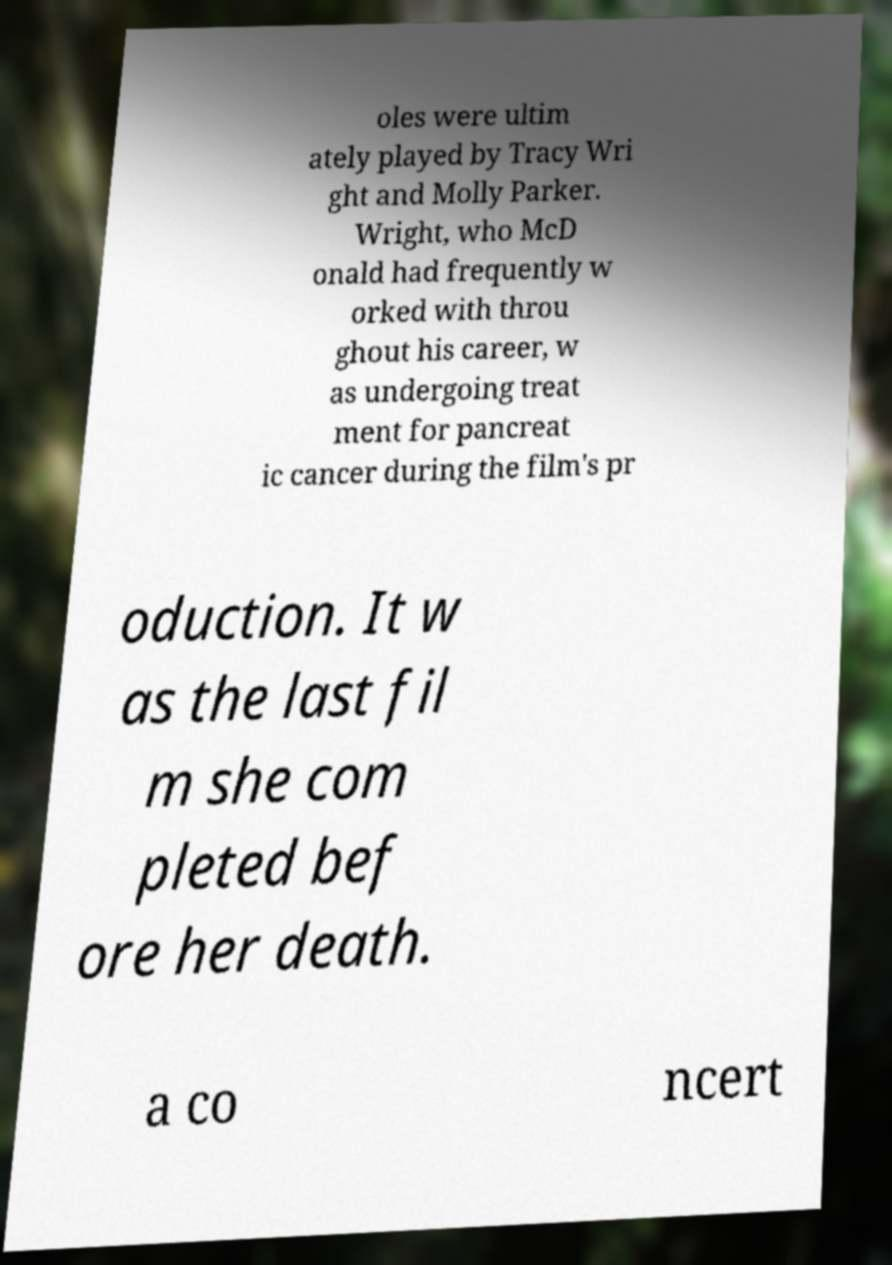There's text embedded in this image that I need extracted. Can you transcribe it verbatim? oles were ultim ately played by Tracy Wri ght and Molly Parker. Wright, who McD onald had frequently w orked with throu ghout his career, w as undergoing treat ment for pancreat ic cancer during the film's pr oduction. It w as the last fil m she com pleted bef ore her death. a co ncert 